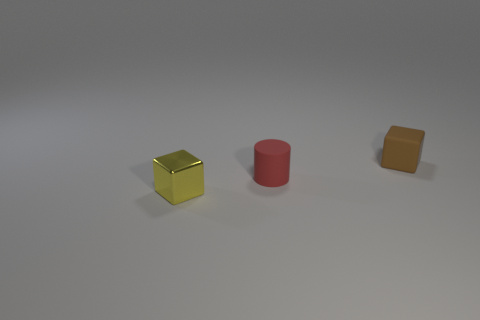There is another thing that is the same shape as the tiny yellow metallic object; what is its size?
Give a very brief answer. Small. Do the cylinder and the cube that is to the left of the tiny brown matte cube have the same material?
Your response must be concise. No. How many blocks are brown rubber objects or yellow objects?
Provide a short and direct response. 2. Are any matte things visible?
Provide a short and direct response. Yes. Are there any other things that have the same shape as the small red rubber thing?
Offer a terse response. No. Is the color of the rubber block the same as the tiny cylinder?
Your response must be concise. No. How many objects are either blocks to the right of the yellow metal block or small metallic things?
Provide a succinct answer. 2. What number of tiny cubes are left of the rubber thing that is in front of the cube that is on the right side of the tiny yellow block?
Ensure brevity in your answer.  1. What shape is the small rubber object on the left side of the tiny cube that is behind the tiny block on the left side of the tiny brown rubber cube?
Your response must be concise. Cylinder. How many other things are there of the same color as the tiny rubber block?
Make the answer very short. 0. 